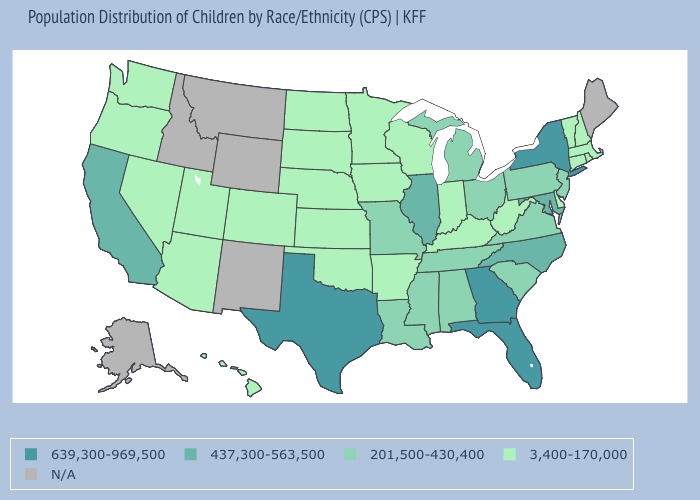What is the value of Nebraska?
Give a very brief answer. 3,400-170,000. What is the value of North Carolina?
Write a very short answer. 437,300-563,500. Name the states that have a value in the range 639,300-969,500?
Be succinct. Florida, Georgia, New York, Texas. Which states have the lowest value in the West?
Write a very short answer. Arizona, Colorado, Hawaii, Nevada, Oregon, Utah, Washington. What is the value of Maryland?
Concise answer only. 437,300-563,500. Name the states that have a value in the range 639,300-969,500?
Give a very brief answer. Florida, Georgia, New York, Texas. What is the value of Vermont?
Concise answer only. 3,400-170,000. What is the highest value in states that border Maryland?
Quick response, please. 201,500-430,400. Which states have the highest value in the USA?
Answer briefly. Florida, Georgia, New York, Texas. Name the states that have a value in the range N/A?
Concise answer only. Alaska, Idaho, Maine, Montana, New Mexico, Wyoming. Which states have the lowest value in the USA?
Concise answer only. Arizona, Arkansas, Colorado, Connecticut, Delaware, Hawaii, Indiana, Iowa, Kansas, Kentucky, Massachusetts, Minnesota, Nebraska, Nevada, New Hampshire, North Dakota, Oklahoma, Oregon, Rhode Island, South Dakota, Utah, Vermont, Washington, West Virginia, Wisconsin. How many symbols are there in the legend?
Be succinct. 5. 